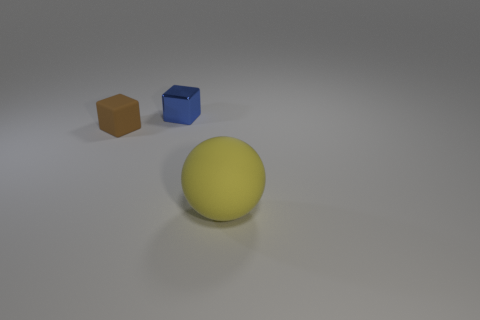Add 2 large yellow matte objects. How many objects exist? 5 Subtract all blocks. How many objects are left? 1 Add 3 gray balls. How many gray balls exist? 3 Subtract 0 cyan cylinders. How many objects are left? 3 Subtract all tiny blue metallic objects. Subtract all big yellow matte things. How many objects are left? 1 Add 1 big matte spheres. How many big matte spheres are left? 2 